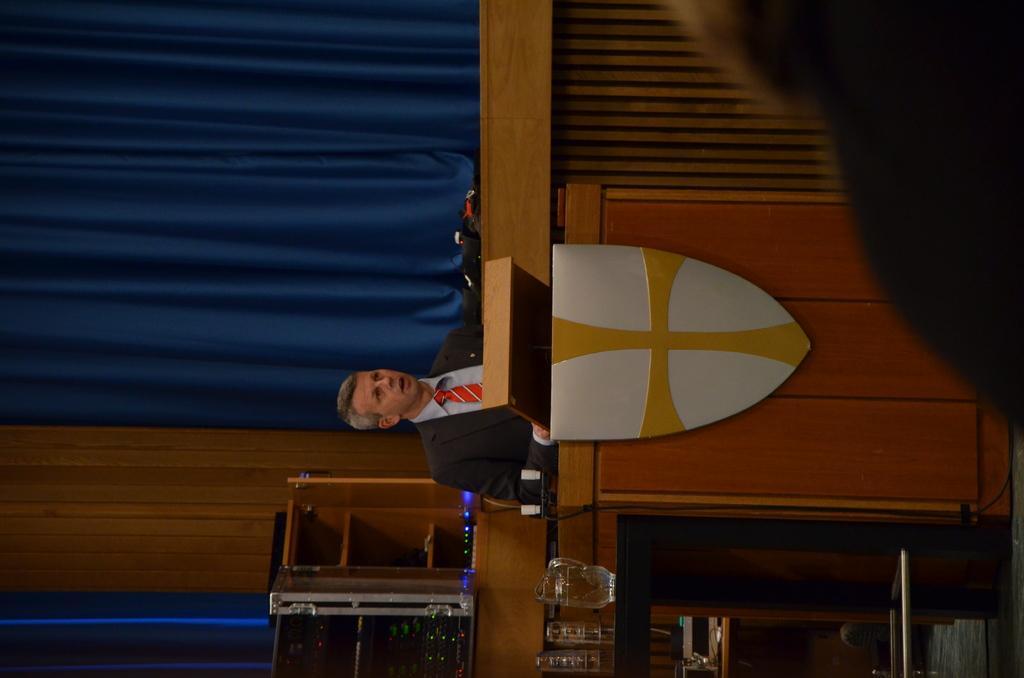In one or two sentences, can you explain what this image depicts? In this image I can see a person wearing black blazer, blue shirt and red tie is standing in front of a podium. In the background I can see a glass mug , the blue colored curtain and few other objects. 